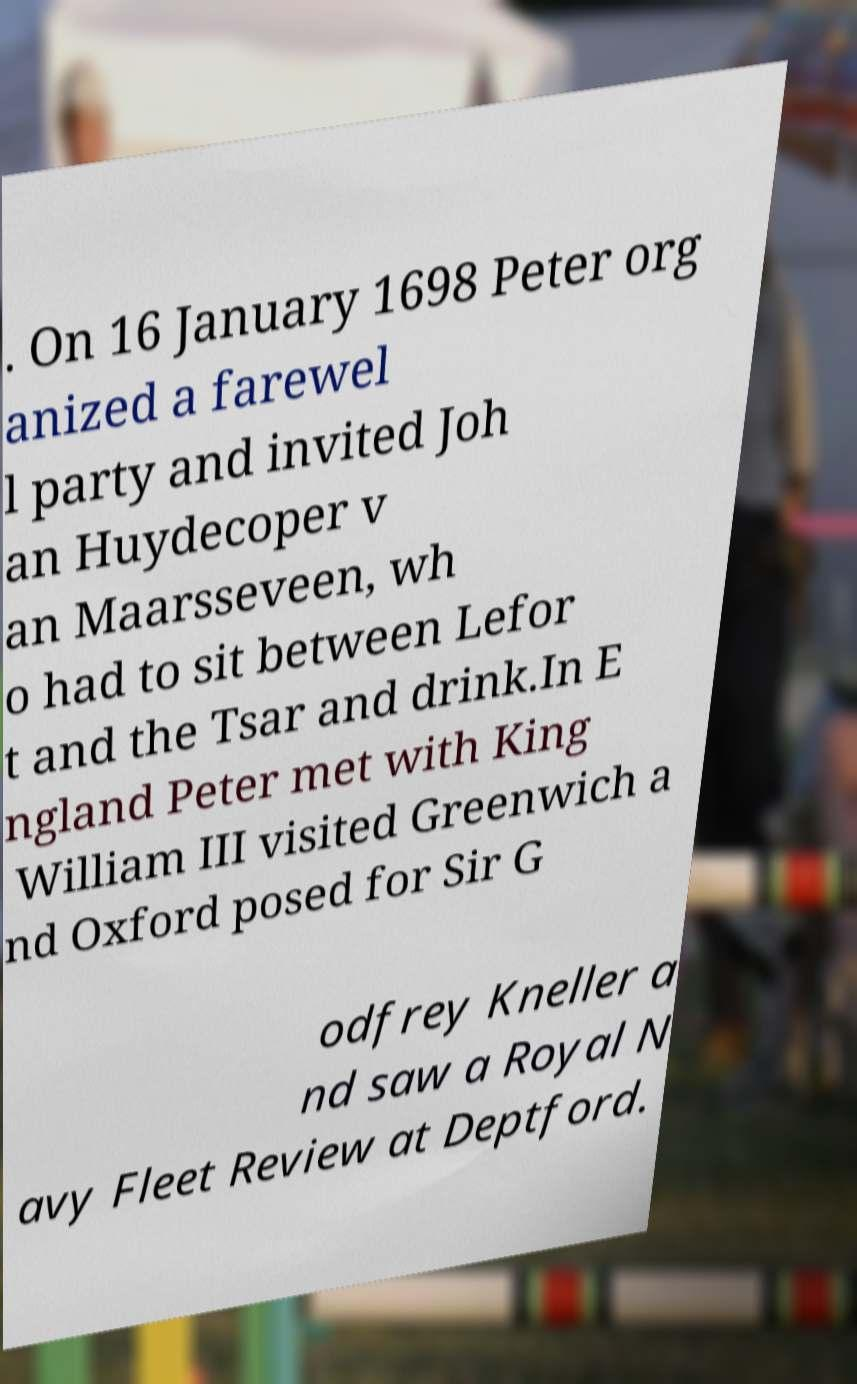For documentation purposes, I need the text within this image transcribed. Could you provide that? . On 16 January 1698 Peter org anized a farewel l party and invited Joh an Huydecoper v an Maarsseveen, wh o had to sit between Lefor t and the Tsar and drink.In E ngland Peter met with King William III visited Greenwich a nd Oxford posed for Sir G odfrey Kneller a nd saw a Royal N avy Fleet Review at Deptford. 